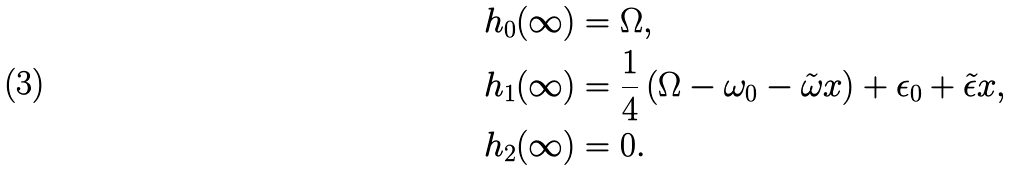<formula> <loc_0><loc_0><loc_500><loc_500>h _ { 0 } ( \infty ) & = { \Omega } , \\ h _ { 1 } ( \infty ) & = \frac { 1 } { 4 } \left ( { \Omega } - \omega _ { 0 } - \tilde { \omega } x \right ) + \epsilon _ { 0 } + \tilde { \epsilon } x , \\ h _ { 2 } ( \infty ) & = 0 .</formula> 